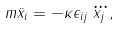Convert formula to latex. <formula><loc_0><loc_0><loc_500><loc_500>m \ddot { x } _ { i } = - \kappa \epsilon _ { i j } \dddot { x _ { j } } ,</formula> 